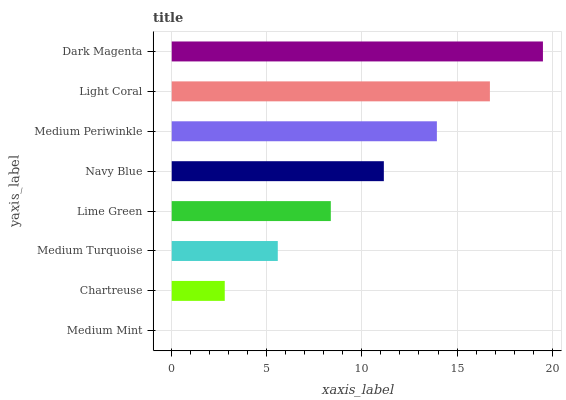Is Medium Mint the minimum?
Answer yes or no. Yes. Is Dark Magenta the maximum?
Answer yes or no. Yes. Is Chartreuse the minimum?
Answer yes or no. No. Is Chartreuse the maximum?
Answer yes or no. No. Is Chartreuse greater than Medium Mint?
Answer yes or no. Yes. Is Medium Mint less than Chartreuse?
Answer yes or no. Yes. Is Medium Mint greater than Chartreuse?
Answer yes or no. No. Is Chartreuse less than Medium Mint?
Answer yes or no. No. Is Navy Blue the high median?
Answer yes or no. Yes. Is Lime Green the low median?
Answer yes or no. Yes. Is Medium Mint the high median?
Answer yes or no. No. Is Navy Blue the low median?
Answer yes or no. No. 